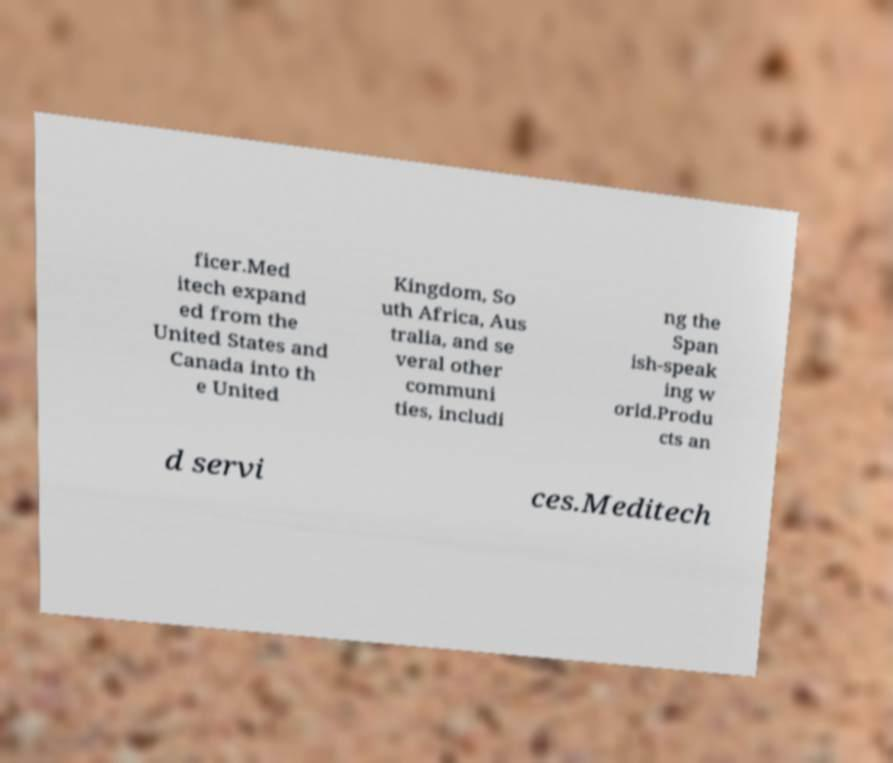For documentation purposes, I need the text within this image transcribed. Could you provide that? ficer.Med itech expand ed from the United States and Canada into th e United Kingdom, So uth Africa, Aus tralia, and se veral other communi ties, includi ng the Span ish-speak ing w orld.Produ cts an d servi ces.Meditech 